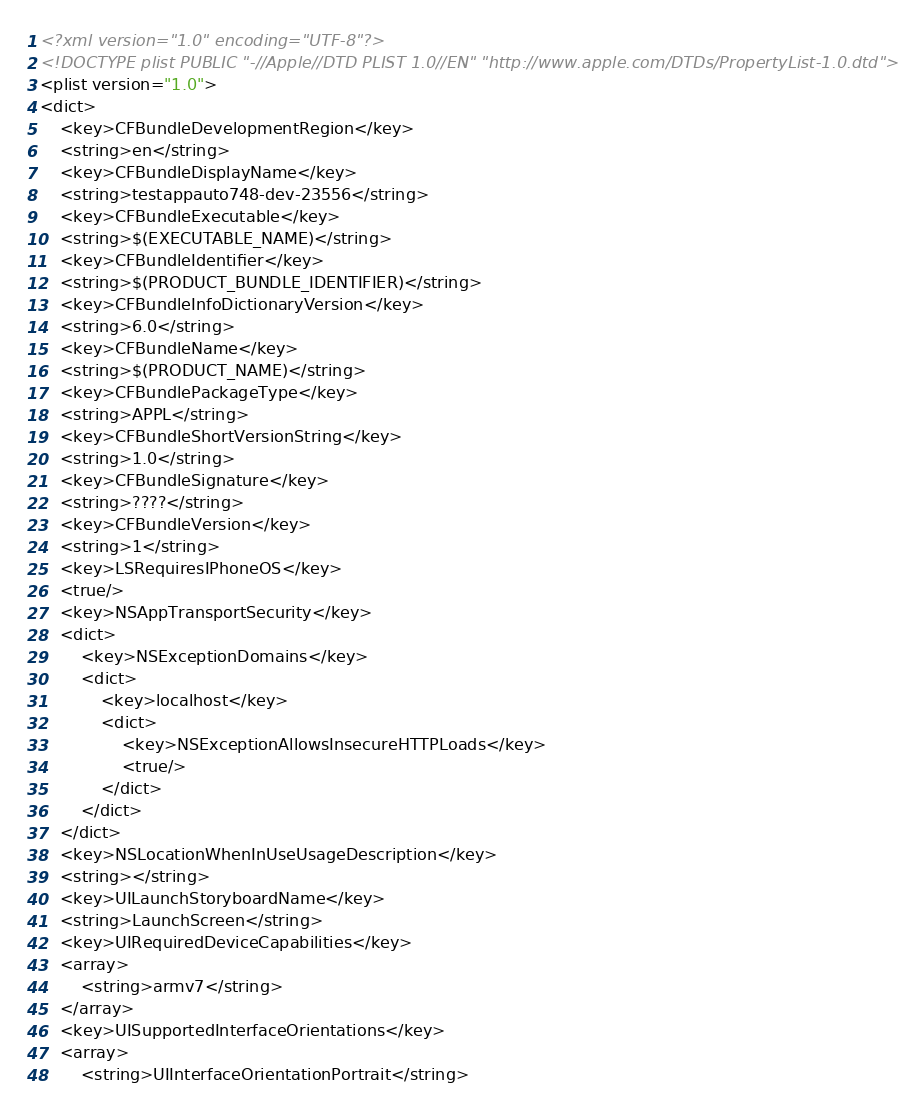<code> <loc_0><loc_0><loc_500><loc_500><_XML_><?xml version="1.0" encoding="UTF-8"?>
<!DOCTYPE plist PUBLIC "-//Apple//DTD PLIST 1.0//EN" "http://www.apple.com/DTDs/PropertyList-1.0.dtd">
<plist version="1.0">
<dict>
	<key>CFBundleDevelopmentRegion</key>
	<string>en</string>
	<key>CFBundleDisplayName</key>
	<string>testappauto748-dev-23556</string>
	<key>CFBundleExecutable</key>
	<string>$(EXECUTABLE_NAME)</string>
	<key>CFBundleIdentifier</key>
	<string>$(PRODUCT_BUNDLE_IDENTIFIER)</string>
	<key>CFBundleInfoDictionaryVersion</key>
	<string>6.0</string>
	<key>CFBundleName</key>
	<string>$(PRODUCT_NAME)</string>
	<key>CFBundlePackageType</key>
	<string>APPL</string>
	<key>CFBundleShortVersionString</key>
	<string>1.0</string>
	<key>CFBundleSignature</key>
	<string>????</string>
	<key>CFBundleVersion</key>
	<string>1</string>
	<key>LSRequiresIPhoneOS</key>
	<true/>
	<key>NSAppTransportSecurity</key>
	<dict>
		<key>NSExceptionDomains</key>
		<dict>
			<key>localhost</key>
			<dict>
				<key>NSExceptionAllowsInsecureHTTPLoads</key>
				<true/>
			</dict>
		</dict>
	</dict>
	<key>NSLocationWhenInUseUsageDescription</key>
	<string></string>
	<key>UILaunchStoryboardName</key>
	<string>LaunchScreen</string>
	<key>UIRequiredDeviceCapabilities</key>
	<array>
		<string>armv7</string>
	</array>
	<key>UISupportedInterfaceOrientations</key>
	<array>
		<string>UIInterfaceOrientationPortrait</string></code> 